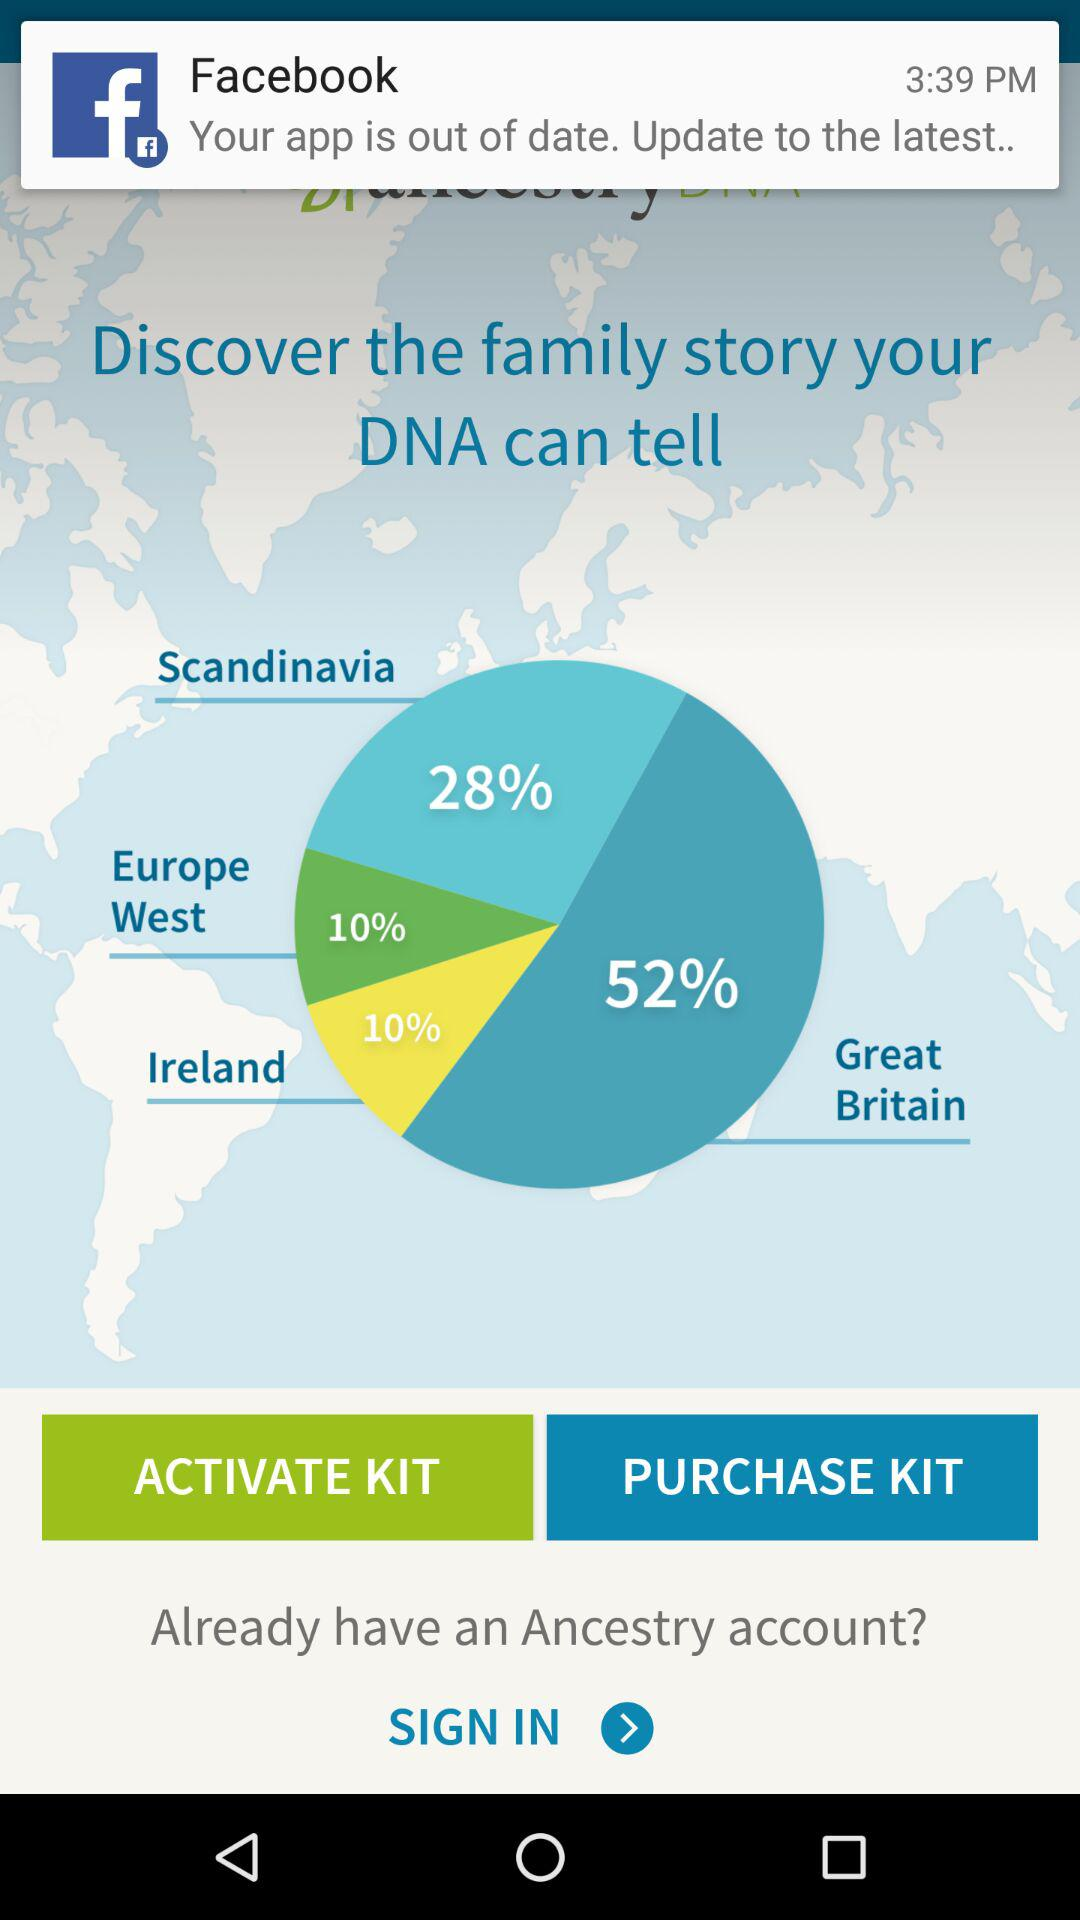How much of a percentage is shown for Great Britain? The percentage shown for Great Britain is 52. 